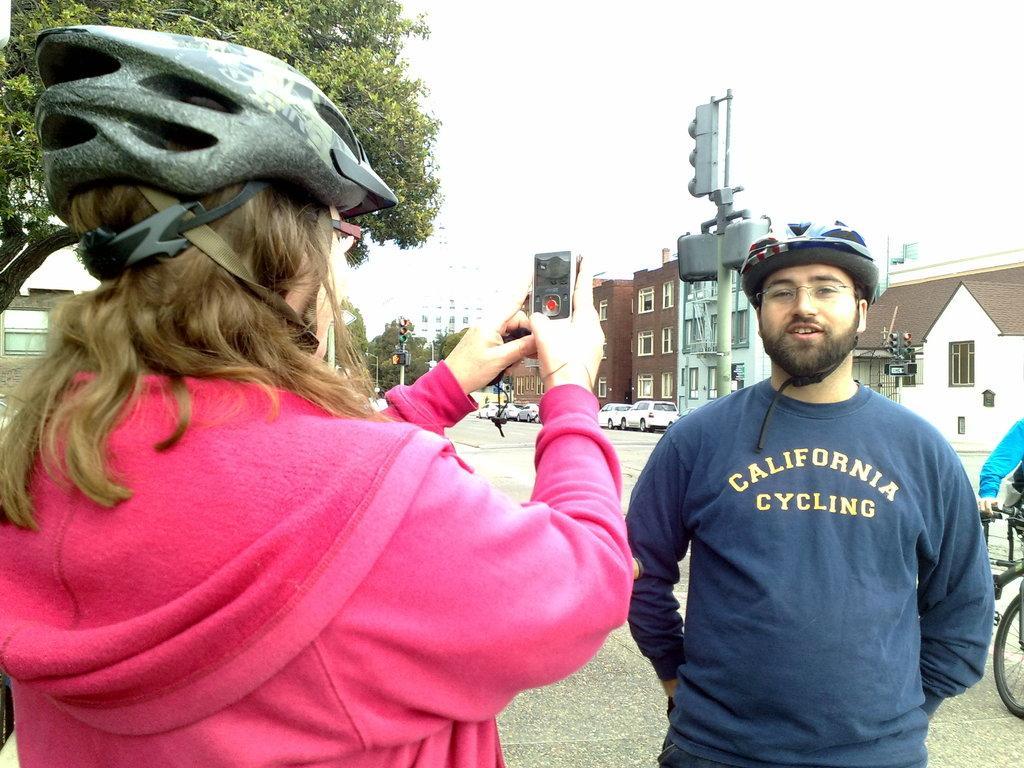Please provide a concise description of this image. In this image I can see a person wearing pink colored dress and black color helmet is standing and holding a mobile. I can see a person standing and in the background I can see few buildings, few trees, few poles, the road, few vehicles on the road, few traffic signals, a person holding a bicycle and the sky. 